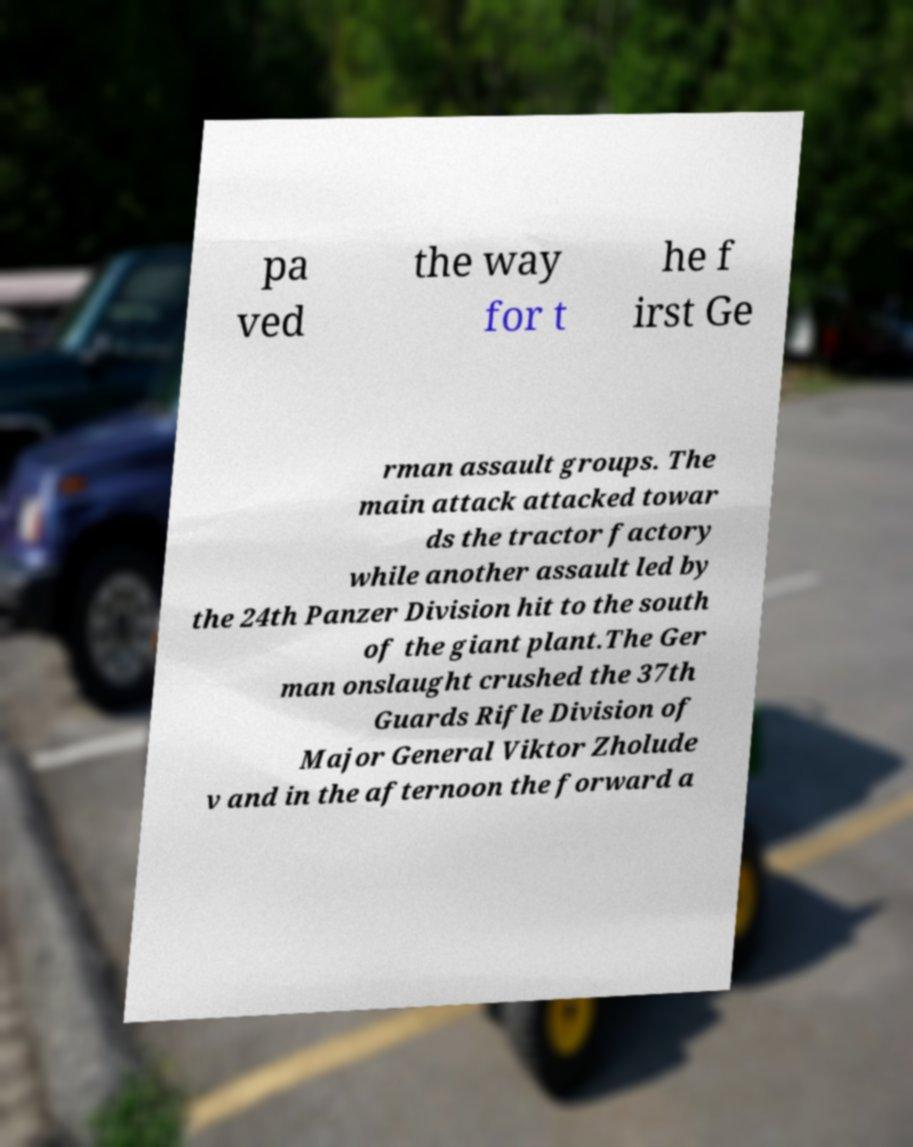Could you extract and type out the text from this image? pa ved the way for t he f irst Ge rman assault groups. The main attack attacked towar ds the tractor factory while another assault led by the 24th Panzer Division hit to the south of the giant plant.The Ger man onslaught crushed the 37th Guards Rifle Division of Major General Viktor Zholude v and in the afternoon the forward a 